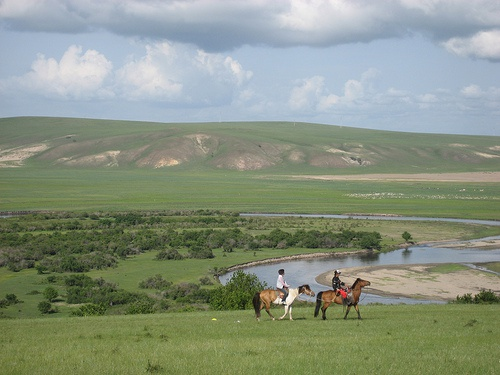Describe the objects in this image and their specific colors. I can see horse in darkgray, black, tan, ivory, and gray tones, horse in darkgray, maroon, black, brown, and gray tones, people in darkgray, black, gray, and maroon tones, and people in darkgray, lightgray, gray, and black tones in this image. 